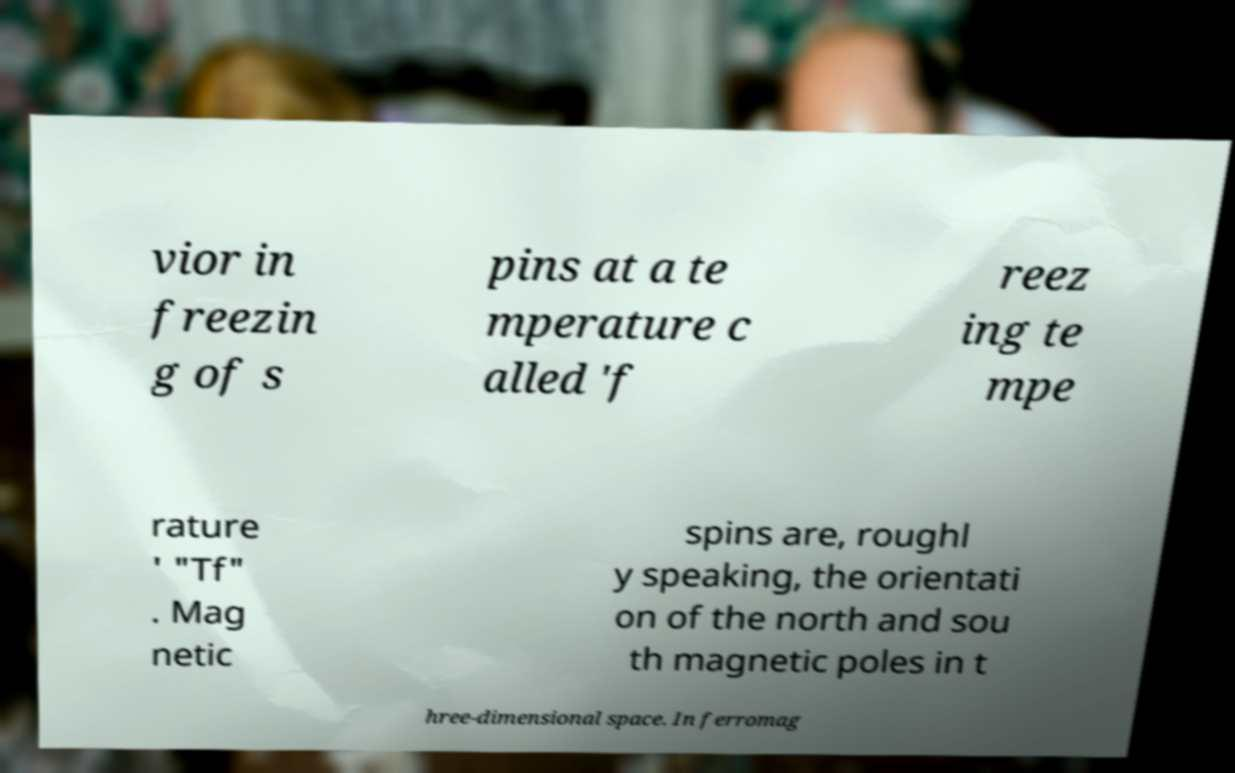Please identify and transcribe the text found in this image. vior in freezin g of s pins at a te mperature c alled 'f reez ing te mpe rature ' "Tf" . Mag netic spins are, roughl y speaking, the orientati on of the north and sou th magnetic poles in t hree-dimensional space. In ferromag 